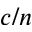<formula> <loc_0><loc_0><loc_500><loc_500>c / n</formula> 